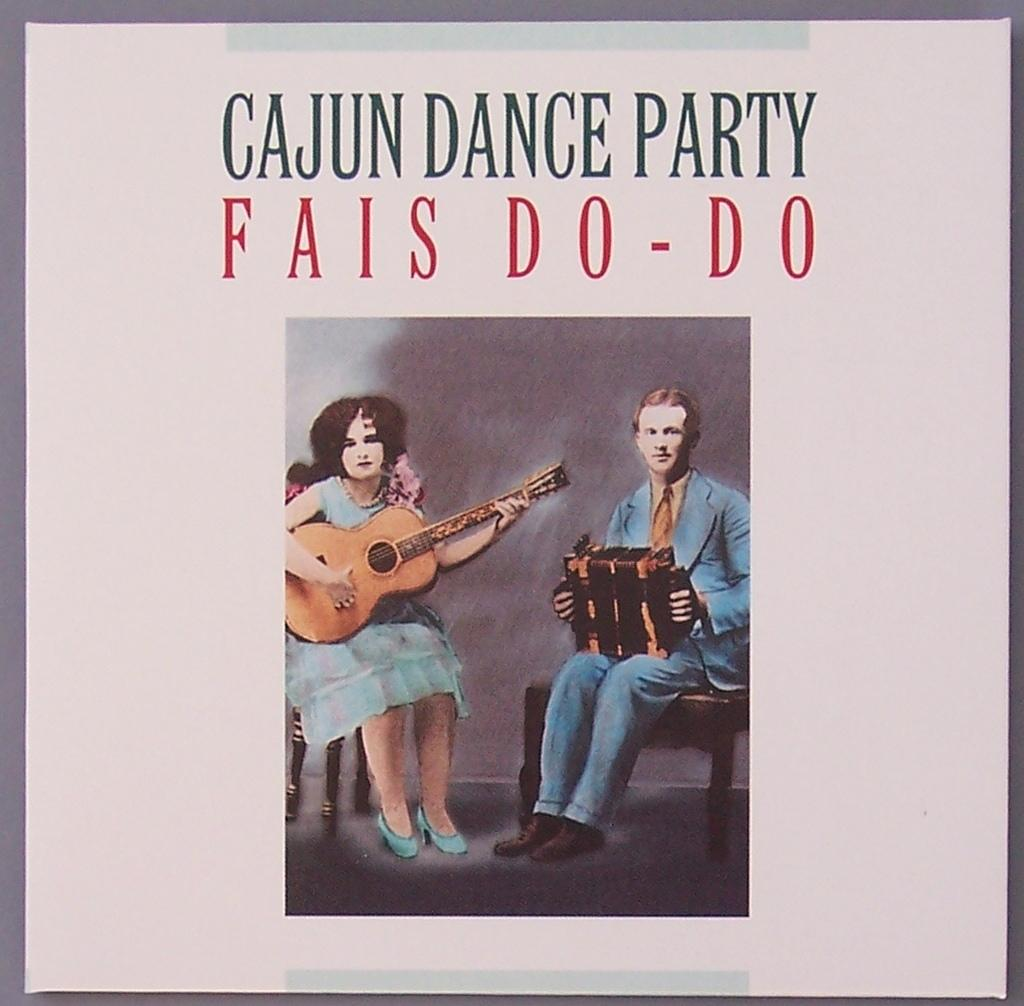What is the main subject of the poster in the image? The main subject of the poster in the image is two persons. What are the persons doing in the poster? The persons are sitting on chairs and playing musical instruments. Is there any text on the poster? Yes, there is text on the poster. How many trees can be seen in the image? There are no trees visible in the image; it features a poster with two persons playing musical instruments. Are the persons in the poster engaged in a fight? No, the persons in the poster are not engaged in a fight; they are playing musical instruments while sitting on chairs. 